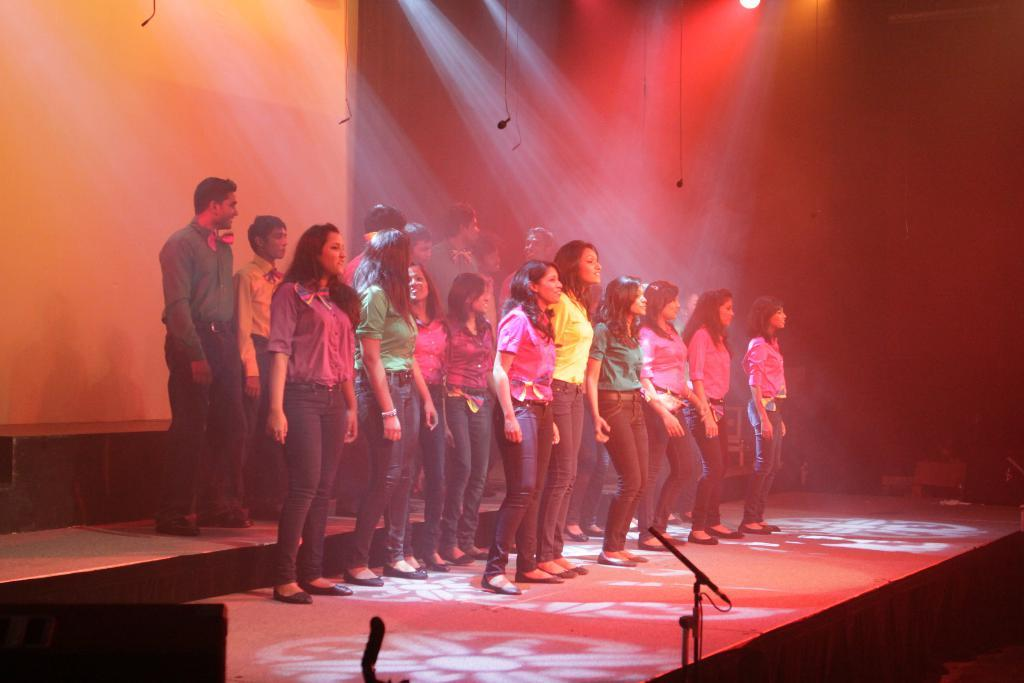What is happening on the stage in the image? There is a group of people standing on the stage. What might the people on the stage be using to amplify their voices? There are microphones (mics) visible in the image. What can be seen in the background of the stage? There is a projector screen and lights visible in the background. What type of mitten is being used to control the lights in the image? There is no mitten present in the image, and the lights are not being controlled by a mitten. 